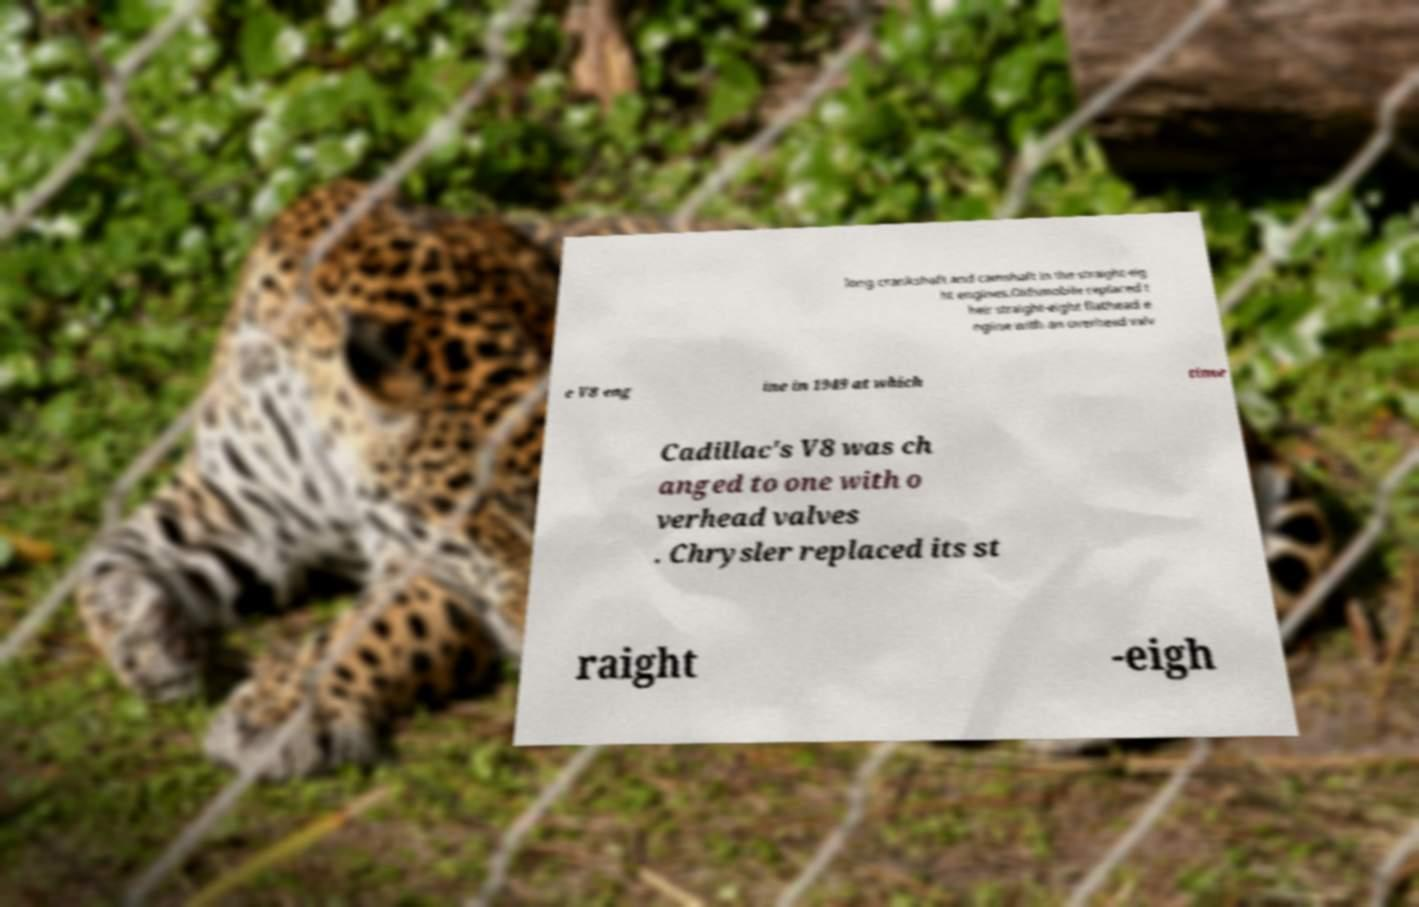Can you accurately transcribe the text from the provided image for me? long crankshaft and camshaft in the straight-eig ht engines.Oldsmobile replaced t heir straight-eight flathead e ngine with an overhead valv e V8 eng ine in 1949 at which time Cadillac's V8 was ch anged to one with o verhead valves . Chrysler replaced its st raight -eigh 